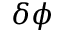<formula> <loc_0><loc_0><loc_500><loc_500>\delta \phi</formula> 